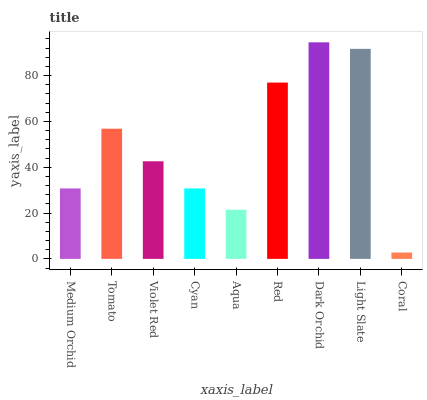Is Coral the minimum?
Answer yes or no. Yes. Is Dark Orchid the maximum?
Answer yes or no. Yes. Is Tomato the minimum?
Answer yes or no. No. Is Tomato the maximum?
Answer yes or no. No. Is Tomato greater than Medium Orchid?
Answer yes or no. Yes. Is Medium Orchid less than Tomato?
Answer yes or no. Yes. Is Medium Orchid greater than Tomato?
Answer yes or no. No. Is Tomato less than Medium Orchid?
Answer yes or no. No. Is Violet Red the high median?
Answer yes or no. Yes. Is Violet Red the low median?
Answer yes or no. Yes. Is Cyan the high median?
Answer yes or no. No. Is Dark Orchid the low median?
Answer yes or no. No. 